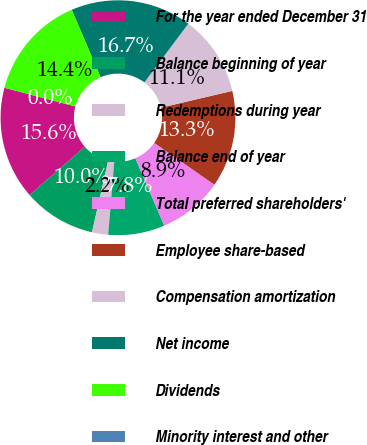<chart> <loc_0><loc_0><loc_500><loc_500><pie_chart><fcel>For the year ended December 31<fcel>Balance beginning of year<fcel>Redemptions during year<fcel>Balance end of year<fcel>Total preferred shareholders'<fcel>Employee share-based<fcel>Compensation amortization<fcel>Net income<fcel>Dividends<fcel>Minority interest and other<nl><fcel>15.55%<fcel>10.0%<fcel>2.22%<fcel>7.78%<fcel>8.89%<fcel>13.33%<fcel>11.11%<fcel>16.67%<fcel>14.44%<fcel>0.0%<nl></chart> 